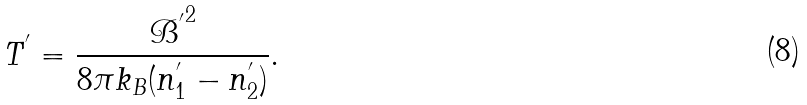<formula> <loc_0><loc_0><loc_500><loc_500>T ^ { ^ { \prime } } = \frac { { \mathcal { B } ^ { ^ { \prime } } } ^ { 2 } } { 8 \pi k _ { B } ( n _ { 1 } ^ { ^ { \prime } } - n _ { 2 } ^ { ^ { \prime } } ) } .</formula> 